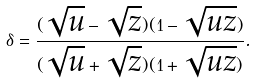Convert formula to latex. <formula><loc_0><loc_0><loc_500><loc_500>\delta = \frac { ( \sqrt { u } - \sqrt { z } ) ( 1 - \sqrt { u z } ) } { ( \sqrt { u } + \sqrt { z } ) ( 1 + \sqrt { u z } ) } .</formula> 